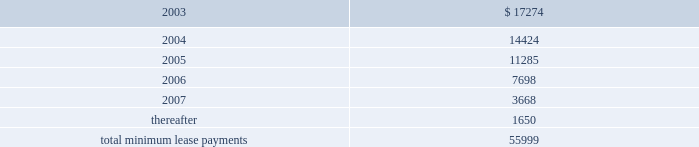Echostar communications corporation notes to consolidated financial statements - continued closing price of the class a common stock on the last business day of each calendar quarter in which such shares of class a common stock are deemed sold to an employee under the espp .
The espp shall terminate upon the first to occur of ( i ) october 1 , 2007 or ( ii ) the date on which the espp is terminated by the board of directors .
During 2000 , 2001 and 2002 employees purchased approximately 58000 ; 80000 and 108000 shares of class a common stock through the espp , respectively .
401 ( k ) employee savings plan echostar sponsors a 401 ( k ) employee savings plan ( the 201c401 ( k ) plan 201d ) for eligible employees .
Voluntary employee contributions to the 401 ( k ) plan may be matched 50% ( 50 % ) by echostar , subject to a maximum annual contribution by echostar of $ 1000 per employee .
Matching 401 ( k ) contributions totaled approximately $ 1.6 million , $ 2.1 million and $ 2.4 million during the years ended december 31 , 2000 , 2001 and 2002 , respectively .
Echostar also may make an annual discretionary contribution to the plan with approval by echostar 2019s board of directors , subject to the maximum deductible limit provided by the internal revenue code of 1986 , as amended .
These contributions may be made in cash or in echostar stock .
Forfeitures of unvested participant balances which are retained by the 401 ( k ) plan may be used to fund matching and discretionary contributions .
Expense recognized relating to discretionary contributions was approximately $ 7 million , $ 225 thousand and $ 17 million during the years ended december 31 , 2000 , 2001 and 2002 , respectively .
Commitments and contingencies leases future minimum lease payments under noncancelable operating leases as of december 31 , 2002 , are as follows ( in thousands ) : year ending december 31 .
Total rent expense for operating leases approximated $ 9 million , $ 14 million and $ 16 million in 2000 , 2001 and 2002 , respectively .
Purchase commitments as of december 31 , 2002 , echostar 2019s purchase commitments totaled approximately $ 359 million .
The majority of these commitments relate to echostar receiver systems and related components .
All of the purchases related to these commitments are expected to be made during 2003 .
Echostar expects to finance these purchases from existing unrestricted cash balances and future cash flows generated from operations .
Patents and intellectual property many entities , including some of echostar 2019s competitors , now have and may in the future obtain patents and other intellectual property rights that cover or affect products or services directly or indirectly related to those that echostar offers .
Echostar may not be aware of all patents and other intellectual property rights that its products may potentially infringe .
Damages in patent infringement cases can include a tripling of actual damages in certain cases .
Further , echostar cannot estimate the extent to which it may be required in the future to obtain licenses with respect to .
What is the percentage change in rent expense for operating leases from 2001 to 2002? 
Computations: ((16 - 14) / 14)
Answer: 0.14286. Echostar communications corporation notes to consolidated financial statements - continued closing price of the class a common stock on the last business day of each calendar quarter in which such shares of class a common stock are deemed sold to an employee under the espp .
The espp shall terminate upon the first to occur of ( i ) october 1 , 2007 or ( ii ) the date on which the espp is terminated by the board of directors .
During 2000 , 2001 and 2002 employees purchased approximately 58000 ; 80000 and 108000 shares of class a common stock through the espp , respectively .
401 ( k ) employee savings plan echostar sponsors a 401 ( k ) employee savings plan ( the 201c401 ( k ) plan 201d ) for eligible employees .
Voluntary employee contributions to the 401 ( k ) plan may be matched 50% ( 50 % ) by echostar , subject to a maximum annual contribution by echostar of $ 1000 per employee .
Matching 401 ( k ) contributions totaled approximately $ 1.6 million , $ 2.1 million and $ 2.4 million during the years ended december 31 , 2000 , 2001 and 2002 , respectively .
Echostar also may make an annual discretionary contribution to the plan with approval by echostar 2019s board of directors , subject to the maximum deductible limit provided by the internal revenue code of 1986 , as amended .
These contributions may be made in cash or in echostar stock .
Forfeitures of unvested participant balances which are retained by the 401 ( k ) plan may be used to fund matching and discretionary contributions .
Expense recognized relating to discretionary contributions was approximately $ 7 million , $ 225 thousand and $ 17 million during the years ended december 31 , 2000 , 2001 and 2002 , respectively .
Commitments and contingencies leases future minimum lease payments under noncancelable operating leases as of december 31 , 2002 , are as follows ( in thousands ) : year ending december 31 .
Total rent expense for operating leases approximated $ 9 million , $ 14 million and $ 16 million in 2000 , 2001 and 2002 , respectively .
Purchase commitments as of december 31 , 2002 , echostar 2019s purchase commitments totaled approximately $ 359 million .
The majority of these commitments relate to echostar receiver systems and related components .
All of the purchases related to these commitments are expected to be made during 2003 .
Echostar expects to finance these purchases from existing unrestricted cash balances and future cash flows generated from operations .
Patents and intellectual property many entities , including some of echostar 2019s competitors , now have and may in the future obtain patents and other intellectual property rights that cover or affect products or services directly or indirectly related to those that echostar offers .
Echostar may not be aware of all patents and other intellectual property rights that its products may potentially infringe .
Damages in patent infringement cases can include a tripling of actual damages in certain cases .
Further , echostar cannot estimate the extent to which it may be required in the future to obtain licenses with respect to .
Are the commitments to acquire echostar receiver systems and related components greater than the commitments for future lease payments? 
Computations: ((359 * 1000) > 55999)
Answer: yes. Echostar communications corporation notes to consolidated financial statements - continued closing price of the class a common stock on the last business day of each calendar quarter in which such shares of class a common stock are deemed sold to an employee under the espp .
The espp shall terminate upon the first to occur of ( i ) october 1 , 2007 or ( ii ) the date on which the espp is terminated by the board of directors .
During 2000 , 2001 and 2002 employees purchased approximately 58000 ; 80000 and 108000 shares of class a common stock through the espp , respectively .
401 ( k ) employee savings plan echostar sponsors a 401 ( k ) employee savings plan ( the 201c401 ( k ) plan 201d ) for eligible employees .
Voluntary employee contributions to the 401 ( k ) plan may be matched 50% ( 50 % ) by echostar , subject to a maximum annual contribution by echostar of $ 1000 per employee .
Matching 401 ( k ) contributions totaled approximately $ 1.6 million , $ 2.1 million and $ 2.4 million during the years ended december 31 , 2000 , 2001 and 2002 , respectively .
Echostar also may make an annual discretionary contribution to the plan with approval by echostar 2019s board of directors , subject to the maximum deductible limit provided by the internal revenue code of 1986 , as amended .
These contributions may be made in cash or in echostar stock .
Forfeitures of unvested participant balances which are retained by the 401 ( k ) plan may be used to fund matching and discretionary contributions .
Expense recognized relating to discretionary contributions was approximately $ 7 million , $ 225 thousand and $ 17 million during the years ended december 31 , 2000 , 2001 and 2002 , respectively .
Commitments and contingencies leases future minimum lease payments under noncancelable operating leases as of december 31 , 2002 , are as follows ( in thousands ) : year ending december 31 .
Total rent expense for operating leases approximated $ 9 million , $ 14 million and $ 16 million in 2000 , 2001 and 2002 , respectively .
Purchase commitments as of december 31 , 2002 , echostar 2019s purchase commitments totaled approximately $ 359 million .
The majority of these commitments relate to echostar receiver systems and related components .
All of the purchases related to these commitments are expected to be made during 2003 .
Echostar expects to finance these purchases from existing unrestricted cash balances and future cash flows generated from operations .
Patents and intellectual property many entities , including some of echostar 2019s competitors , now have and may in the future obtain patents and other intellectual property rights that cover or affect products or services directly or indirectly related to those that echostar offers .
Echostar may not be aware of all patents and other intellectual property rights that its products may potentially infringe .
Damages in patent infringement cases can include a tripling of actual damages in certain cases .
Further , echostar cannot estimate the extent to which it may be required in the future to obtain licenses with respect to .
During 2000 , 2001 and 2002 , what were total employee purchases through the espp? 
Computations: ((58000 + 80000) + 108000)
Answer: 246000.0. Echostar communications corporation notes to consolidated financial statements - continued closing price of the class a common stock on the last business day of each calendar quarter in which such shares of class a common stock are deemed sold to an employee under the espp .
The espp shall terminate upon the first to occur of ( i ) october 1 , 2007 or ( ii ) the date on which the espp is terminated by the board of directors .
During 2000 , 2001 and 2002 employees purchased approximately 58000 ; 80000 and 108000 shares of class a common stock through the espp , respectively .
401 ( k ) employee savings plan echostar sponsors a 401 ( k ) employee savings plan ( the 201c401 ( k ) plan 201d ) for eligible employees .
Voluntary employee contributions to the 401 ( k ) plan may be matched 50% ( 50 % ) by echostar , subject to a maximum annual contribution by echostar of $ 1000 per employee .
Matching 401 ( k ) contributions totaled approximately $ 1.6 million , $ 2.1 million and $ 2.4 million during the years ended december 31 , 2000 , 2001 and 2002 , respectively .
Echostar also may make an annual discretionary contribution to the plan with approval by echostar 2019s board of directors , subject to the maximum deductible limit provided by the internal revenue code of 1986 , as amended .
These contributions may be made in cash or in echostar stock .
Forfeitures of unvested participant balances which are retained by the 401 ( k ) plan may be used to fund matching and discretionary contributions .
Expense recognized relating to discretionary contributions was approximately $ 7 million , $ 225 thousand and $ 17 million during the years ended december 31 , 2000 , 2001 and 2002 , respectively .
Commitments and contingencies leases future minimum lease payments under noncancelable operating leases as of december 31 , 2002 , are as follows ( in thousands ) : year ending december 31 .
Total rent expense for operating leases approximated $ 9 million , $ 14 million and $ 16 million in 2000 , 2001 and 2002 , respectively .
Purchase commitments as of december 31 , 2002 , echostar 2019s purchase commitments totaled approximately $ 359 million .
The majority of these commitments relate to echostar receiver systems and related components .
All of the purchases related to these commitments are expected to be made during 2003 .
Echostar expects to finance these purchases from existing unrestricted cash balances and future cash flows generated from operations .
Patents and intellectual property many entities , including some of echostar 2019s competitors , now have and may in the future obtain patents and other intellectual property rights that cover or affect products or services directly or indirectly related to those that echostar offers .
Echostar may not be aware of all patents and other intellectual property rights that its products may potentially infringe .
Damages in patent infringement cases can include a tripling of actual damages in certain cases .
Further , echostar cannot estimate the extent to which it may be required in the future to obtain licenses with respect to .
What is the expected growth rate in rent expense for operating leases in 2003? 
Computations: (((17274 / 1000) - 16) / 16)
Answer: 0.07963. 